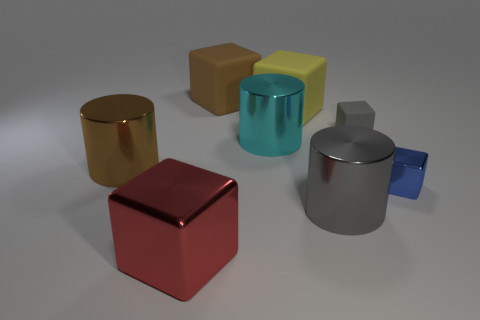Is the size of the brown metal cylinder the same as the blue cube?
Your answer should be compact. No. Is there a brown cylinder that has the same size as the brown matte thing?
Offer a very short reply. Yes. Are there fewer small blue metal objects than large cylinders?
Offer a terse response. Yes. What shape is the shiny thing that is left of the large object that is in front of the large shiny object that is right of the large cyan object?
Provide a succinct answer. Cylinder. How many objects are rubber cubes that are to the right of the big brown block or big blocks behind the brown cylinder?
Keep it short and to the point. 3. There is a large red shiny object; are there any tiny gray matte objects on the right side of it?
Keep it short and to the point. Yes. How many objects are big rubber cubes that are in front of the large brown rubber object or tiny gray matte cylinders?
Offer a terse response. 1. How many red objects are either big cylinders or large metallic blocks?
Offer a very short reply. 1. What number of other objects are the same color as the tiny shiny block?
Your answer should be compact. 0. Is the number of gray objects right of the gray cylinder less than the number of big red matte cubes?
Offer a terse response. No. 